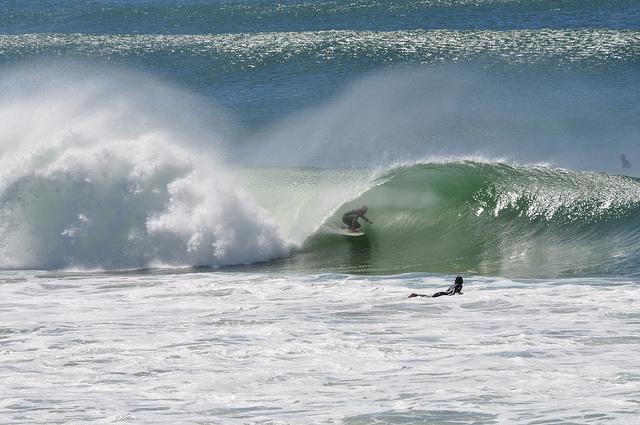Where is the venue?
Give a very brief answer. Ocean. What is this person riding?
Quick response, please. Surfboard. Is he standing on a surfboard?
Concise answer only. Yes. Is this person on a beach?
Answer briefly. Yes. 